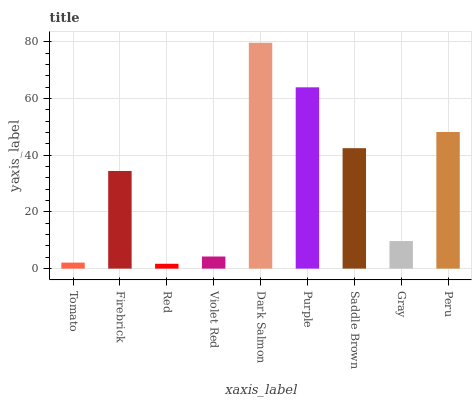Is Red the minimum?
Answer yes or no. Yes. Is Dark Salmon the maximum?
Answer yes or no. Yes. Is Firebrick the minimum?
Answer yes or no. No. Is Firebrick the maximum?
Answer yes or no. No. Is Firebrick greater than Tomato?
Answer yes or no. Yes. Is Tomato less than Firebrick?
Answer yes or no. Yes. Is Tomato greater than Firebrick?
Answer yes or no. No. Is Firebrick less than Tomato?
Answer yes or no. No. Is Firebrick the high median?
Answer yes or no. Yes. Is Firebrick the low median?
Answer yes or no. Yes. Is Violet Red the high median?
Answer yes or no. No. Is Dark Salmon the low median?
Answer yes or no. No. 